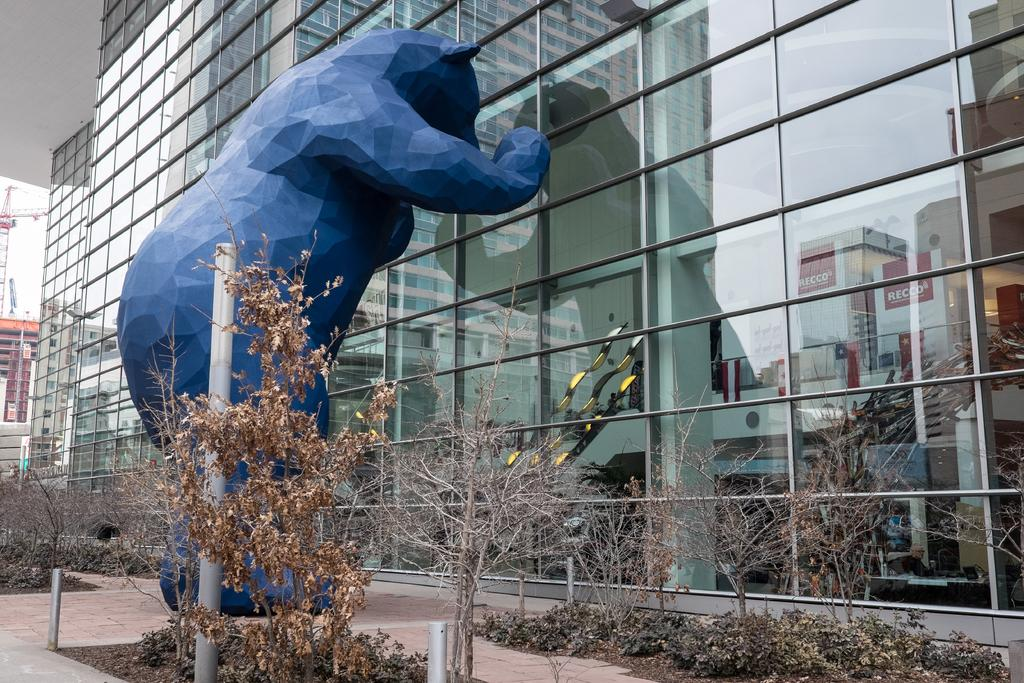What type of structures can be seen in the image? There are buildings in the image. What kind of statue is present in the image? There is a statue of an animal in the image. What type of vegetation is visible in the image? There are trees in the image. What might be used to control access or direct traffic in the image? There are barriers in the image. What equipment is visible in the image that is typically used for construction? There are construction cranes in the image. What part of the natural environment is visible in the image? The sky is visible in the image. What year is depicted in the image? The image does not depict a specific year; it is a static representation of the scene. What type of wax is used to create the statue in the image? There is no information about the materials used to create the statue in the image. What type of house is visible in the image? There is no house visible in the image; only buildings, a statue, trees, barriers, construction cranes, and the sky are present. 